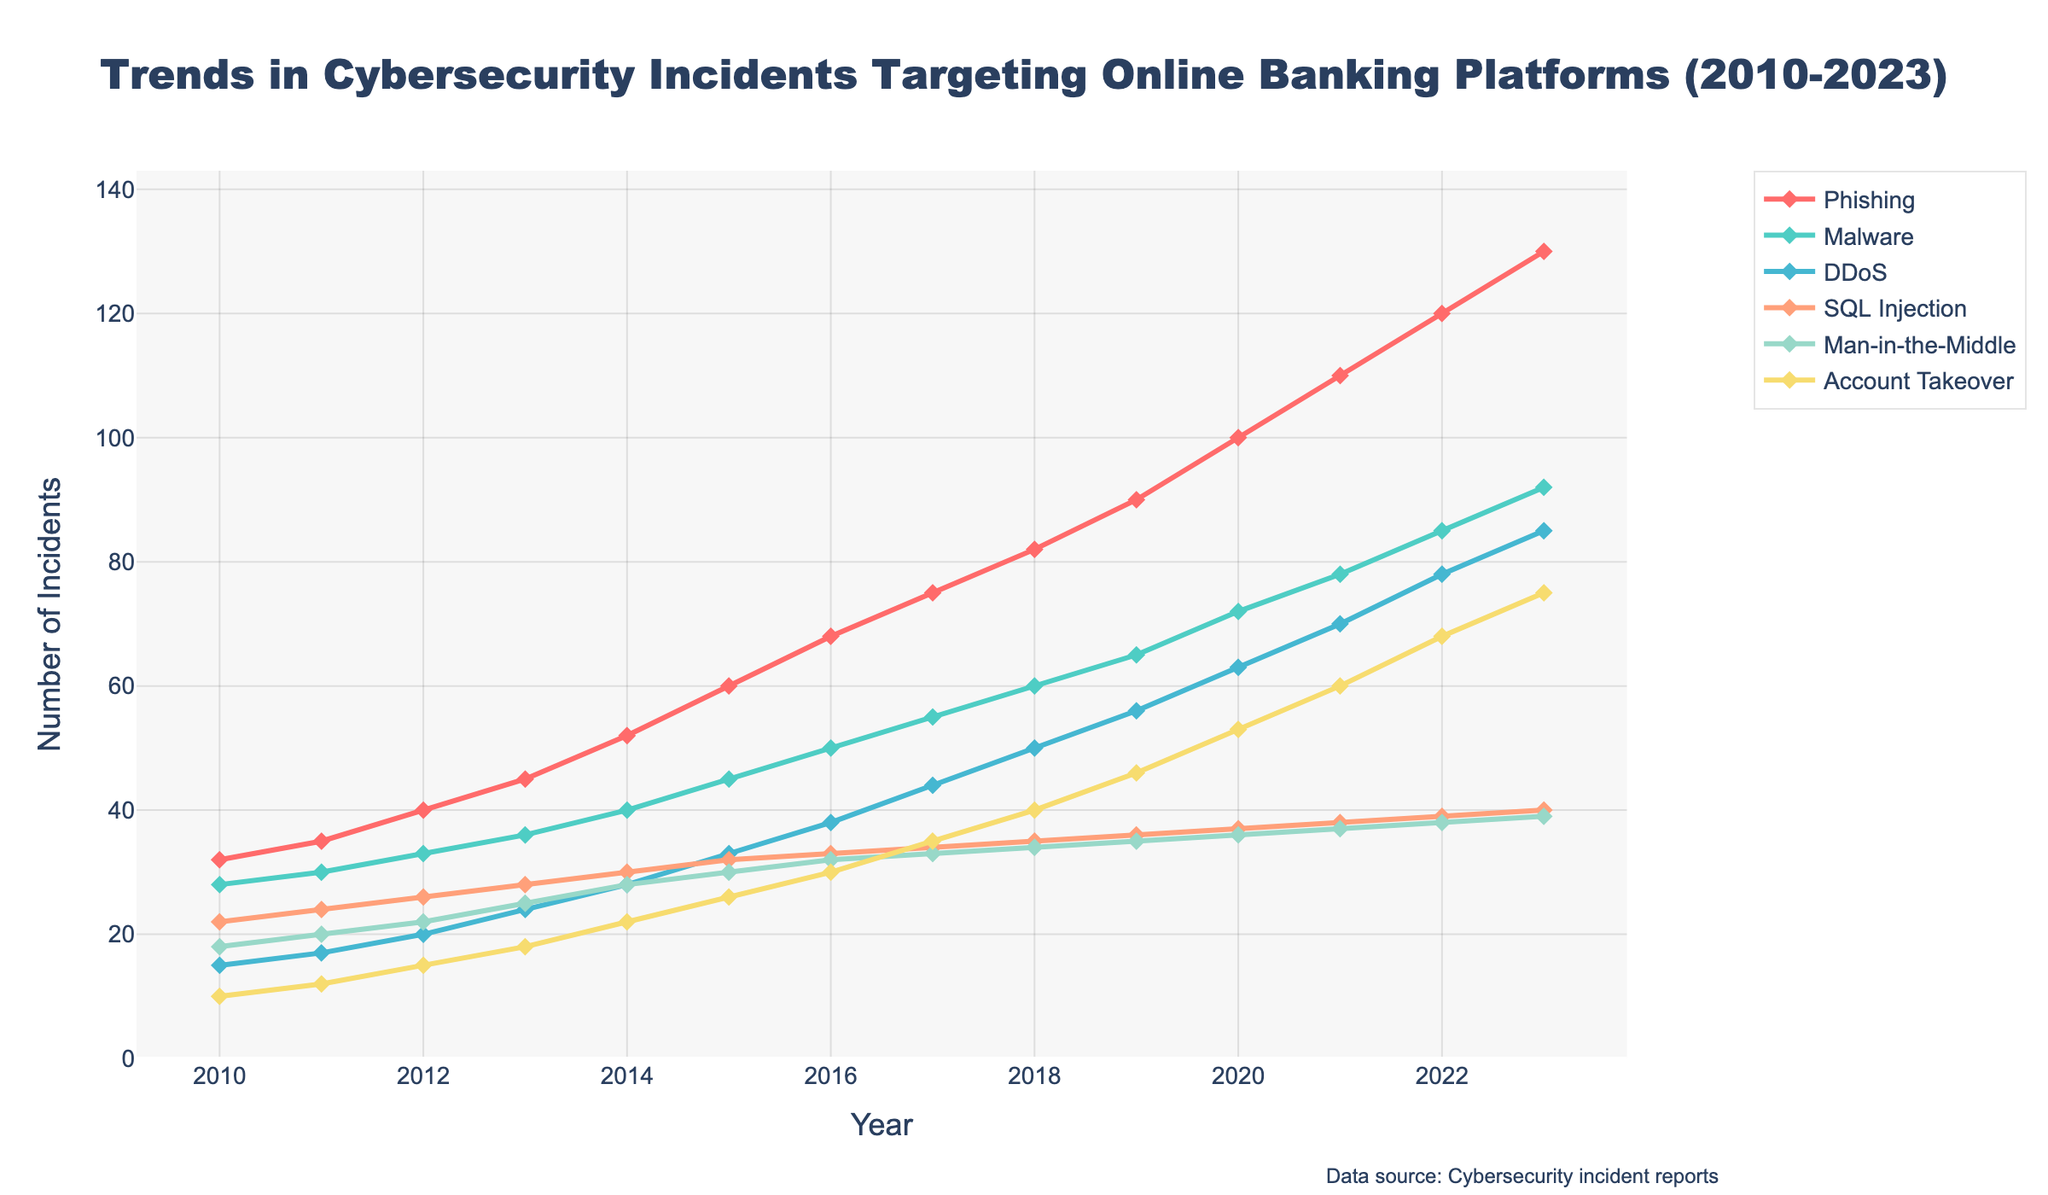What type of attack had the highest number of incidents in 2023? The line representing "Phishing" is highest at the rightmost end of the chart for the year 2023.
Answer: Phishing Between which years did "Malware" incidents see the largest increase? By observing the steepest increase in the plotted line for "Malware," we see between 2014 and 2015, "Malware" incidents increased the most from 40 to 45.
Answer: 2014-2015 Which attack type had a steady increase without any decline throughout the period 2010 to 2023? Each attack type must be observed to determine if the line always goes upwards without any drops. "Phishing" consistently increases without any declines.
Answer: Phishing How many more "Phishing" incidents were recorded in 2023 compared to 2010? Subtract the number of "Phishing" incidents in 2010 (32) from the number in 2023 (130). 130 - 32 = 98.
Answer: 98 Which attack type had the smallest number of incidents in 2020? The line lowest among all attack types for the year 2020 is "SQL Injection" with 37 incidents.
Answer: SQL Injection What is the trend in "DDoS" attacks from 2010 to 2023? The line for "DDoS" attacks shows a steady increase from 15 in 2010 to 85 in 2023, indicating a consistent upward trend.
Answer: Upward trend Compare the number of "Account Takeover" incidents between 2015 and 2023. "Account Takeover" incidents were 26 in 2015 and 75 in 2023. First, subtract 26 from 75. 75 - 26 = 49.
Answer: 49 Which four years had an equal number of "Man-in-the-Middle" incidents? Observing the line for "Man-in-the-Middle," it stays at 30 from 2015 to 2017, and at 36 from 2019 to 2021, indicating two sets of three consecutive years.
Answer: 2015-2017 and 2019-2021 How many total incidents of "SQL Injection" occurred between 2010 and 2023? Add all individual counts for "SQL Injection" across the years 2010 to 2023: 22 + 24 + 26 + 28 + 30 + 32 + 33 + 34 + 35 + 36 + 37 + 38 + 39 + 40 = 444.
Answer: 444 What was the average number of "Man-in-the-Middle" incidents for the first five years (2010-2014)? Add the number of "Man-in-the-Middle" incidents from 2010 to 2014 (18, 20, 22, 25, 28) and divide by 5: (18 + 20 + 22 + 25 + 28) / 5 = 22.6.
Answer: 22.6 